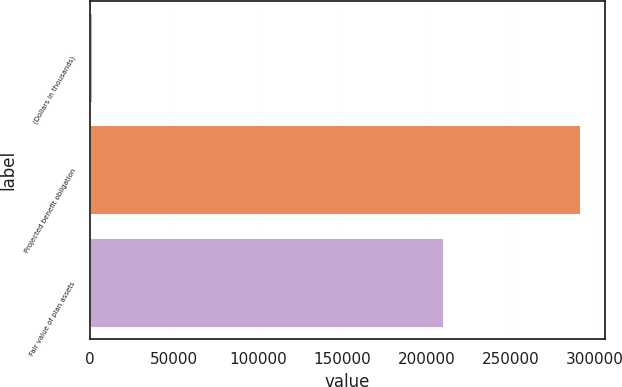<chart> <loc_0><loc_0><loc_500><loc_500><bar_chart><fcel>(Dollars in thousands)<fcel>Projected benefit obligation<fcel>Fair value of plan assets<nl><fcel>2017<fcel>291720<fcel>210267<nl></chart> 